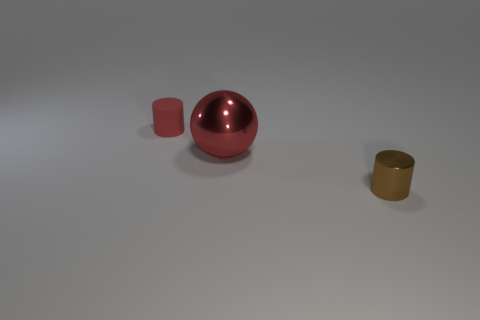What is the shape of the red thing that is to the left of the large red ball?
Give a very brief answer. Cylinder. Are there any other things that have the same material as the tiny red thing?
Your response must be concise. No. Is the number of large things in front of the large thing greater than the number of spheres?
Provide a short and direct response. No. What number of large metallic spheres are in front of the metal thing to the left of the cylinder that is to the right of the red metal ball?
Provide a succinct answer. 0. There is a red object to the left of the red shiny thing; is it the same size as the cylinder that is in front of the large red metal thing?
Offer a terse response. Yes. There is a small cylinder on the left side of the cylinder that is on the right side of the rubber cylinder; what is its material?
Ensure brevity in your answer.  Rubber. What number of objects are small things to the right of the small red cylinder or red things?
Give a very brief answer. 3. Are there an equal number of brown objects behind the metallic cylinder and brown metal cylinders behind the large thing?
Ensure brevity in your answer.  Yes. There is a big object that is in front of the cylinder left of the cylinder in front of the large shiny ball; what is it made of?
Your answer should be very brief. Metal. What size is the object that is to the left of the tiny shiny thing and in front of the red matte cylinder?
Give a very brief answer. Large. 